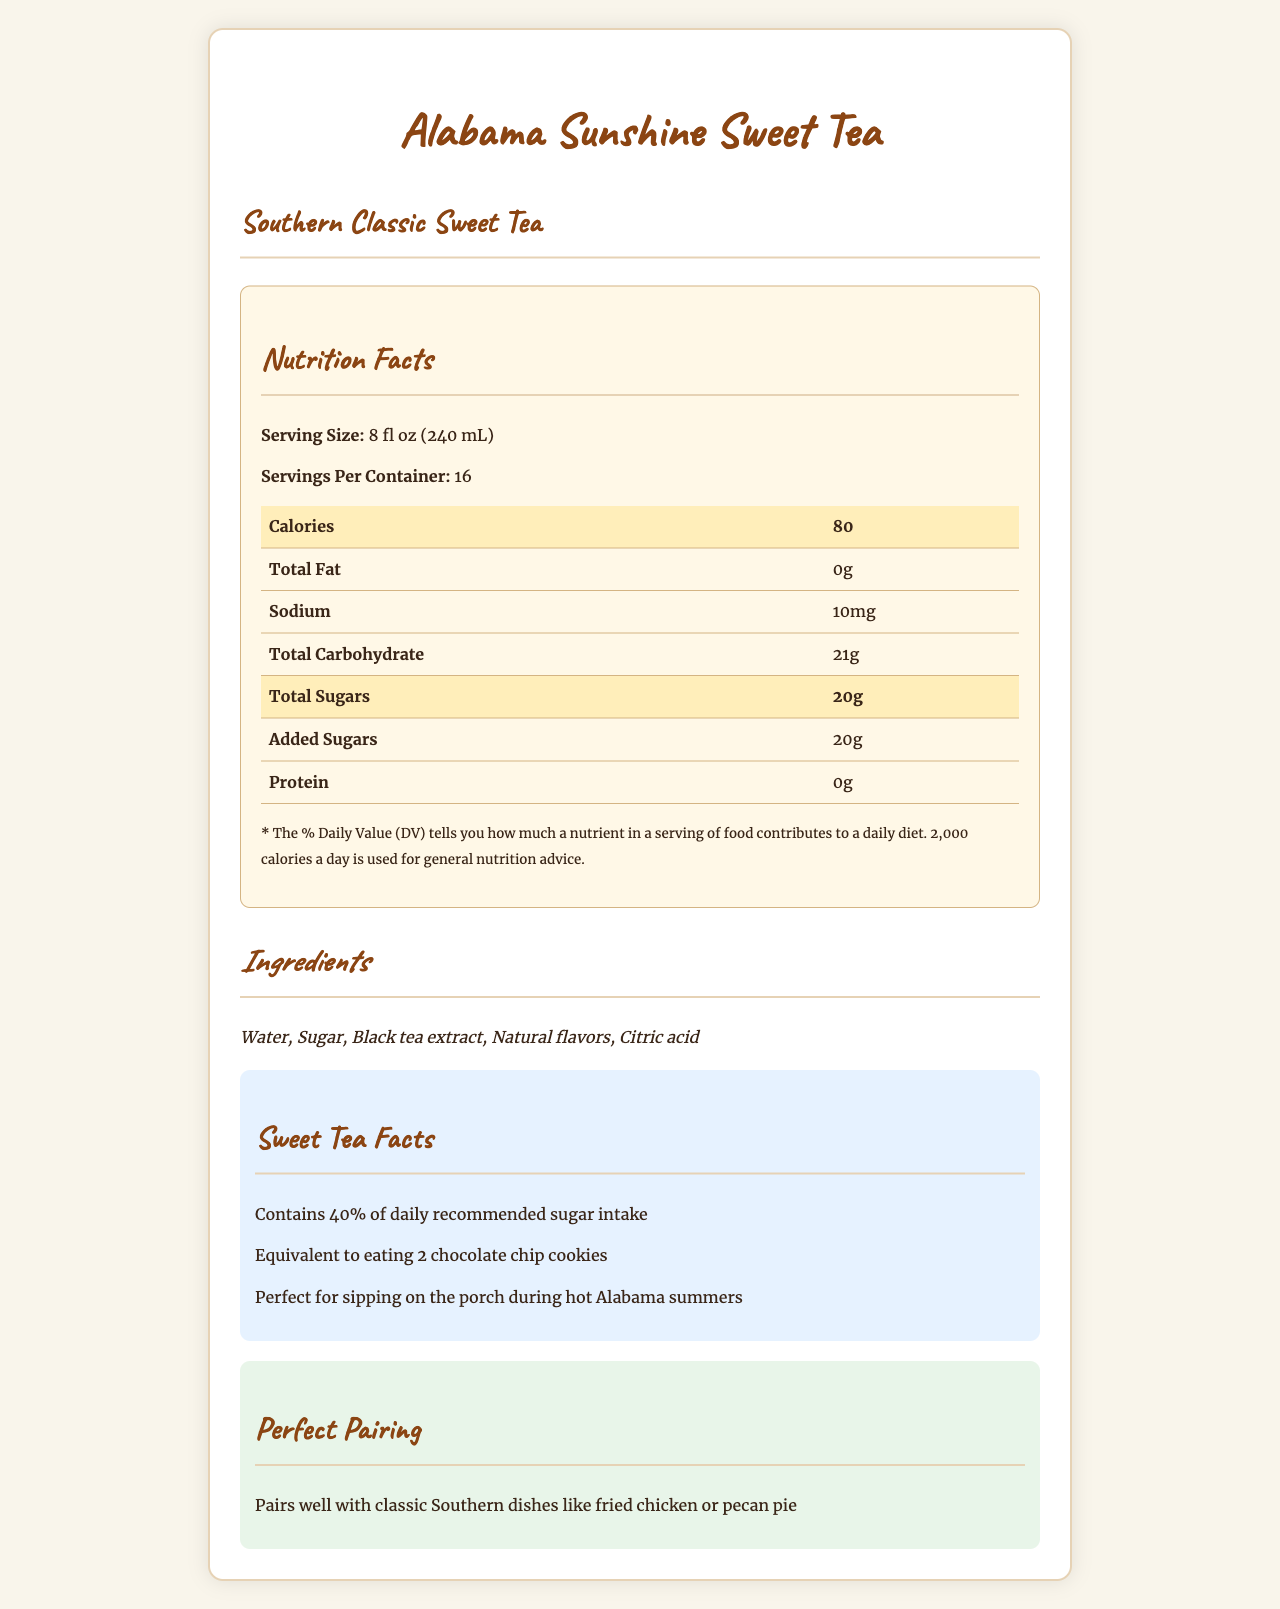what is the serving size? The serving size is listed directly under the `Nutrition Facts` heading, stating "Serving Size: 8 fl oz (240 mL)".
Answer: 8 fl oz (240 mL) how many calories are in one serving? The document highlights the calories per serving with emphasis, showing "Calories: 80".
Answer: 80 how much sodium does one serving contain? Under the `Nutrition Facts` section, it is stated that each serving contains 10mg of sodium.
Answer: 10mg how many grams of total sugars are in each serving? The document highlights the total sugars per serving as 20g.
Answer: 20g how much protein is in one serving? In the `Nutrition Facts` table, it lists protein content per serving as 0g.
Answer: 0g which ingredient is listed first? A. Black tea extract B. Citric acid C. Sugar D. Water The first ingredient listed is Water.
Answer: D how many servings are in the container? A. 8 B. 10 C. 16 D. 20 The number of servings per container is listed as 16.
Answer: C does this product contain any common allergens? Under `Allergen Information`, the document states "No common allergens".
Answer: No what is the recommended pairing for this sweet tea? The pairing suggestion mentions it pairs well with classic Southern dishes like fried chicken or pecan pie.
Answer: Classic Southern dishes like fried chicken or pecan pie what percentage of the daily recommended sugar intake does one serving of this sweet tea provide? In the `Sweet Tea Facts` section, it highlights that it contains 40% of the daily recommended sugar intake.
Answer: 40% how does the document describe the sugar content highlight? The document states this in the `Sweet Tea Facts` section.
Answer: "Contains 40% of daily recommended sugar intake" how many grams of added sugars are in one serving? The document lists added sugars per serving as 20g in the `Nutrition Facts` table.
Answer: 20g what is the main idea of this document? The document provides detailed nutritional facts, ingredients, allergen information, and contextual notes like southern charm and pairing suggestions.
Answer: Nutritional information and contextual details about Southern Classic Sweet Tea by Alabama Sunshine Sweet Tea. what vitamins and minerals are present in this sweet tea? The document shows 0% for Vitamin C, Calcium, Iron, and Potassium.
Answer: None listed is there citric acid in this sweet tea? It is mentioned in the ingredients list.
Answer: Yes how does the calorie content of the sweet tea compare to other foods? The document mentions this in the `Sweet Tea Facts` section.
Answer: Equivalent to eating 2 chocolate chip cookies what is the total fat content in the sweet tea? The `Nutrition Facts` table lists the total fat content per serving as 0g.
Answer: 0g is the tea made with artificial flavors? The ingredients list only "Natural flavors".
Answer: No how does the document describe enjoying the sweet tea in a Southern context? This description is provided in the `Sweet Tea Facts` section.
Answer: Perfect for sipping on the porch during hot Alabama summers how much total carbohydrate is in each serving? In the `Nutrition Facts` table, total carbohydrate per serving is listed as 21g.
Answer: 21g how many calories are in the entire container? With 80 calories per serving and 16 servings per container, the total is 80 * 16 = 1280.
Answer: 1280 does the document provide information on caffeine content? There is no mention of caffeine content in the provided document.
Answer: Not enough information 